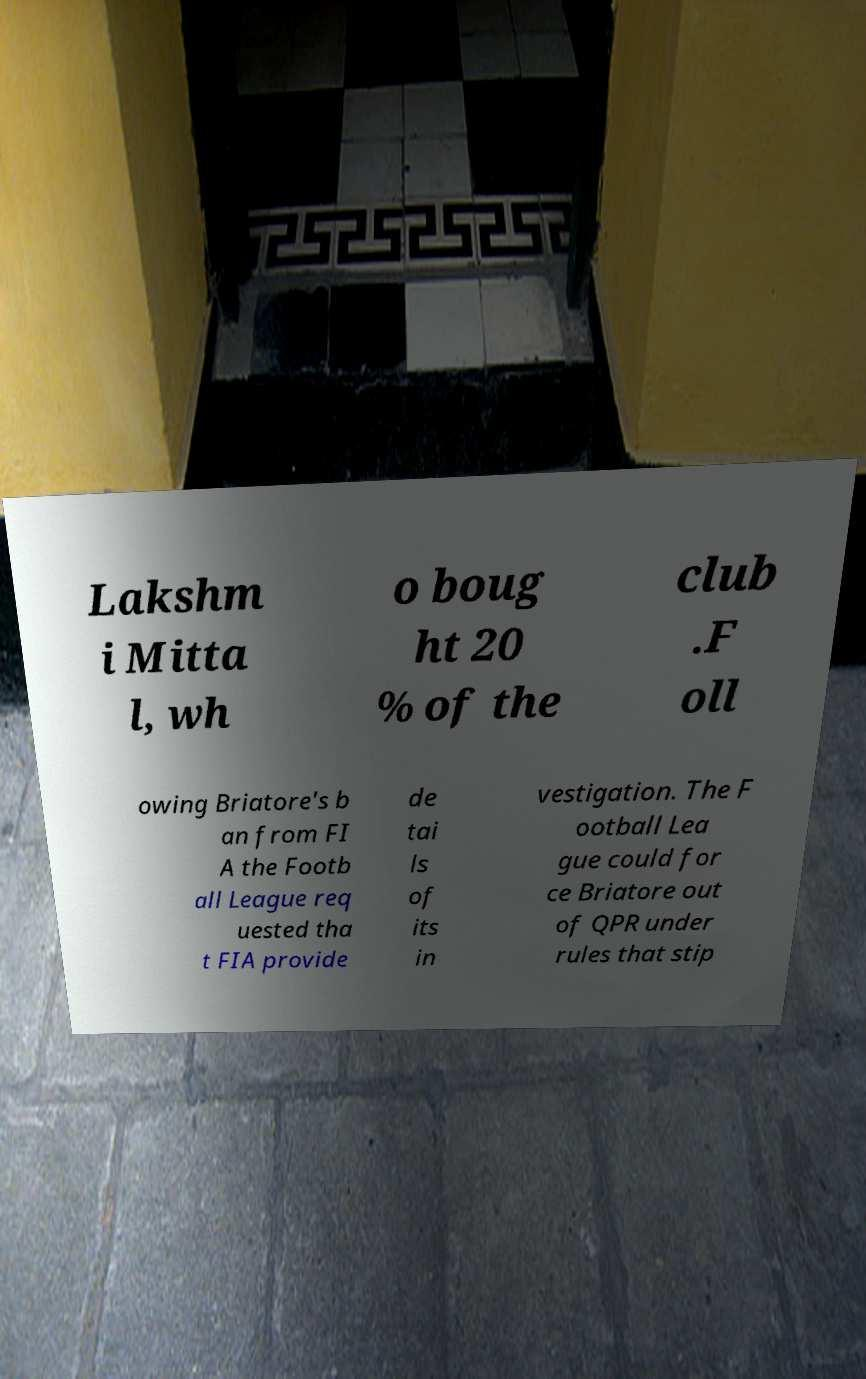There's text embedded in this image that I need extracted. Can you transcribe it verbatim? Lakshm i Mitta l, wh o boug ht 20 % of the club .F oll owing Briatore's b an from FI A the Footb all League req uested tha t FIA provide de tai ls of its in vestigation. The F ootball Lea gue could for ce Briatore out of QPR under rules that stip 